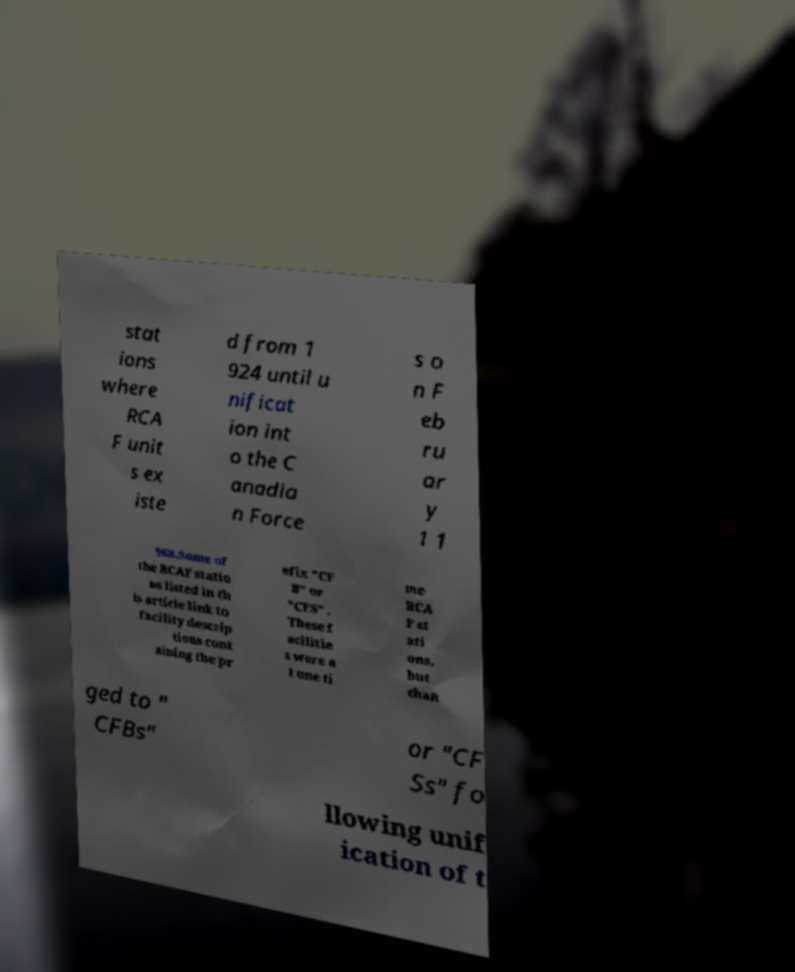Can you read and provide the text displayed in the image?This photo seems to have some interesting text. Can you extract and type it out for me? stat ions where RCA F unit s ex iste d from 1 924 until u nificat ion int o the C anadia n Force s o n F eb ru ar y 1 1 968.Some of the RCAF statio ns listed in th is article link to facility descrip tions cont aining the pr efix "CF B" or "CFS" . These f acilitie s were a t one ti me RCA F st ati ons, but chan ged to " CFBs" or "CF Ss" fo llowing unif ication of t 